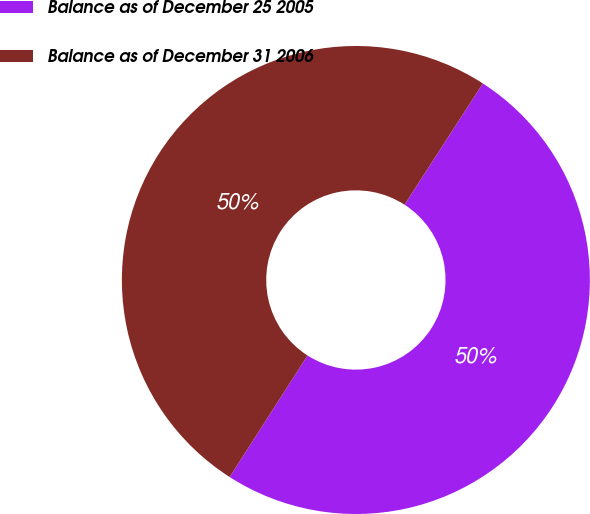Convert chart. <chart><loc_0><loc_0><loc_500><loc_500><pie_chart><fcel>Balance as of December 25 2005<fcel>Balance as of December 31 2006<nl><fcel>49.94%<fcel>50.06%<nl></chart> 